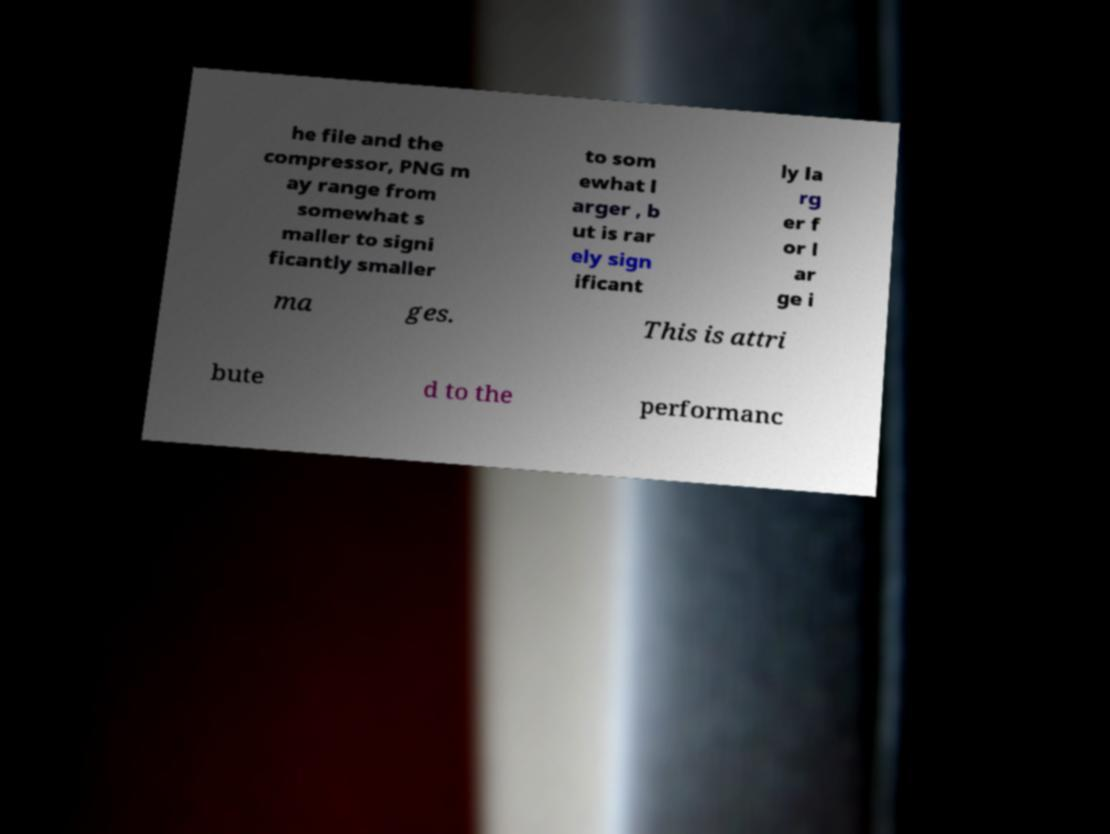For documentation purposes, I need the text within this image transcribed. Could you provide that? he file and the compressor, PNG m ay range from somewhat s maller to signi ficantly smaller to som ewhat l arger , b ut is rar ely sign ificant ly la rg er f or l ar ge i ma ges. This is attri bute d to the performanc 